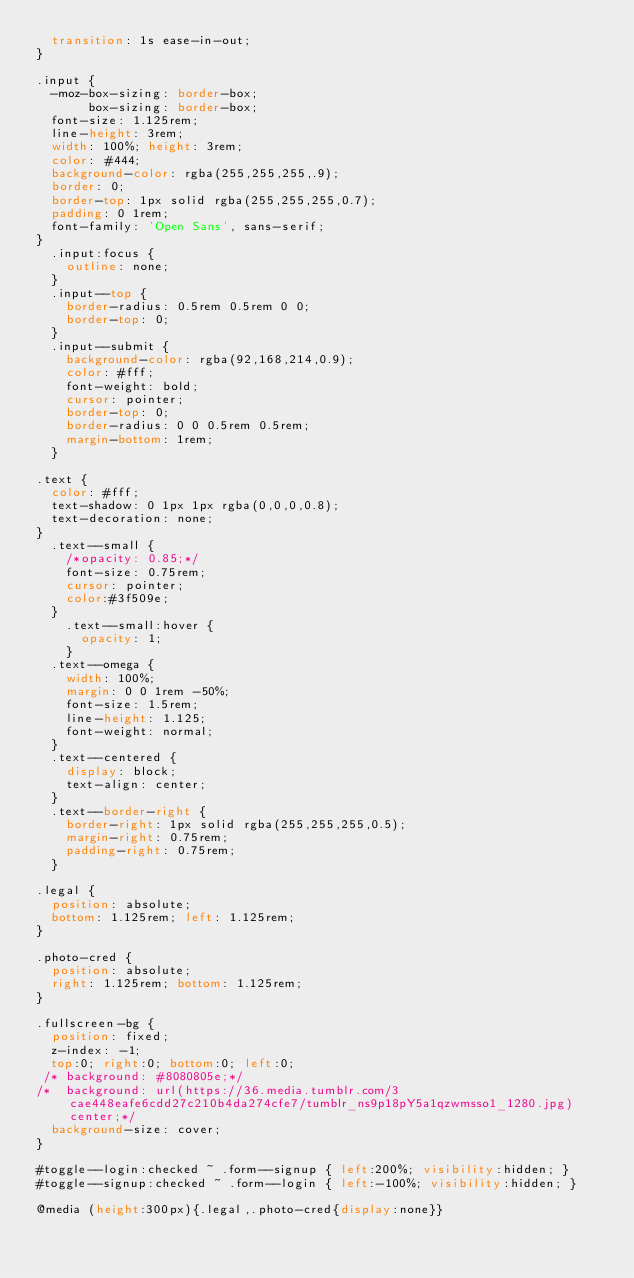<code> <loc_0><loc_0><loc_500><loc_500><_CSS_>  transition: 1s ease-in-out;
}

.input {
  -moz-box-sizing: border-box;
       box-sizing: border-box;
  font-size: 1.125rem;
  line-height: 3rem;
  width: 100%; height: 3rem;
  color: #444;
  background-color: rgba(255,255,255,.9);
  border: 0;
  border-top: 1px solid rgba(255,255,255,0.7);
  padding: 0 1rem;
  font-family: 'Open Sans', sans-serif;
}
  .input:focus {
    outline: none;
  }
  .input--top {
    border-radius: 0.5rem 0.5rem 0 0;
    border-top: 0;
  }
  .input--submit {
    background-color: rgba(92,168,214,0.9);
    color: #fff;
    font-weight: bold;
    cursor: pointer;
    border-top: 0;
    border-radius: 0 0 0.5rem 0.5rem;
    margin-bottom: 1rem;
  }

.text {
  color: #fff;
  text-shadow: 0 1px 1px rgba(0,0,0,0.8);
  text-decoration: none;
}
  .text--small {
    /*opacity: 0.85;*/
    font-size: 0.75rem;
    cursor: pointer;
    color:#3f509e;
  }
    .text--small:hover {
      opacity: 1;
    }
  .text--omega {
    width: 100%;
    margin: 0 0 1rem -50%;
    font-size: 1.5rem;
    line-height: 1.125;
    font-weight: normal;
  }
  .text--centered {
    display: block;
    text-align: center;
  }
  .text--border-right {
    border-right: 1px solid rgba(255,255,255,0.5);
    margin-right: 0.75rem;
    padding-right: 0.75rem;
  }

.legal {
  position: absolute;
  bottom: 1.125rem; left: 1.125rem;
}

.photo-cred {
  position: absolute;
  right: 1.125rem; bottom: 1.125rem;
}

.fullscreen-bg {
  position: fixed;
  z-index: -1;
  top:0; right:0; bottom:0; left:0;
 /* background: #8080805e;*/
/*  background: url(https://36.media.tumblr.com/3cae448eafe6cdd27c210b4da274cfe7/tumblr_ns9p18pY5a1qzwmsso1_1280.jpg) center;*/
  background-size: cover;
}

#toggle--login:checked ~ .form--signup { left:200%; visibility:hidden; }
#toggle--signup:checked ~ .form--login { left:-100%; visibility:hidden; }

@media (height:300px){.legal,.photo-cred{display:none}}</code> 